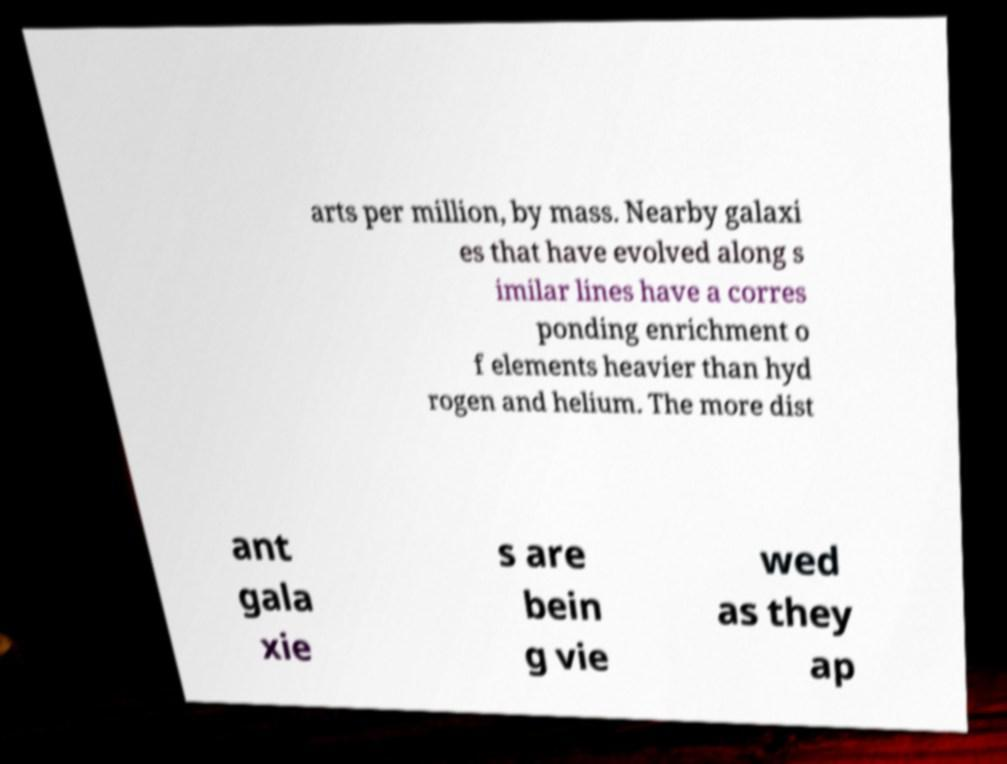Can you accurately transcribe the text from the provided image for me? arts per million, by mass. Nearby galaxi es that have evolved along s imilar lines have a corres ponding enrichment o f elements heavier than hyd rogen and helium. The more dist ant gala xie s are bein g vie wed as they ap 